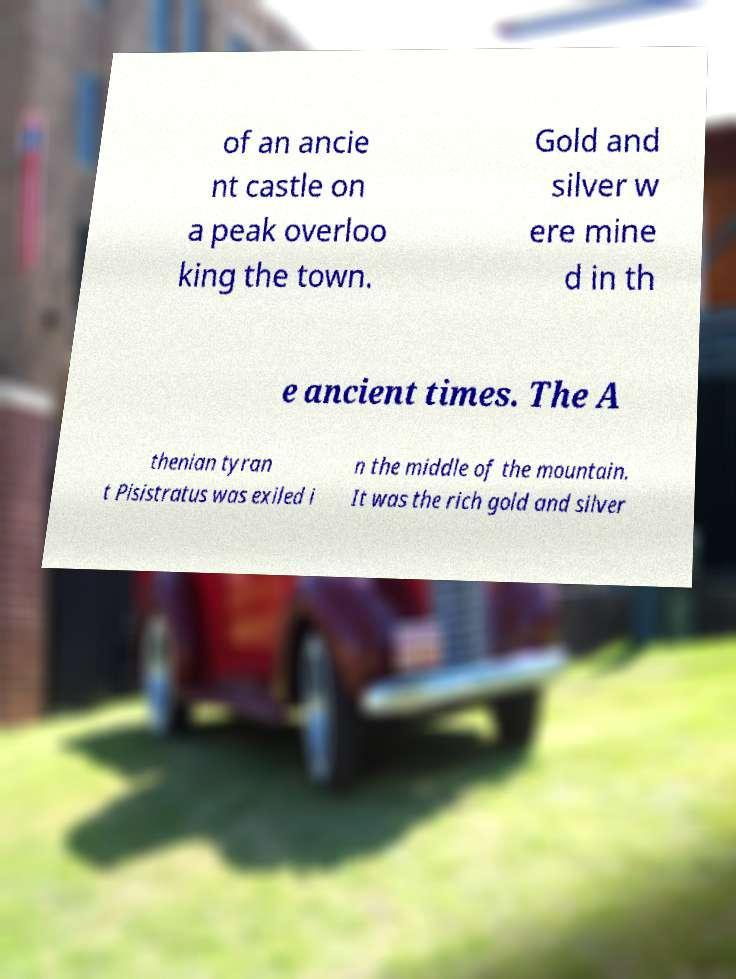Could you extract and type out the text from this image? of an ancie nt castle on a peak overloo king the town. Gold and silver w ere mine d in th e ancient times. The A thenian tyran t Pisistratus was exiled i n the middle of the mountain. It was the rich gold and silver 